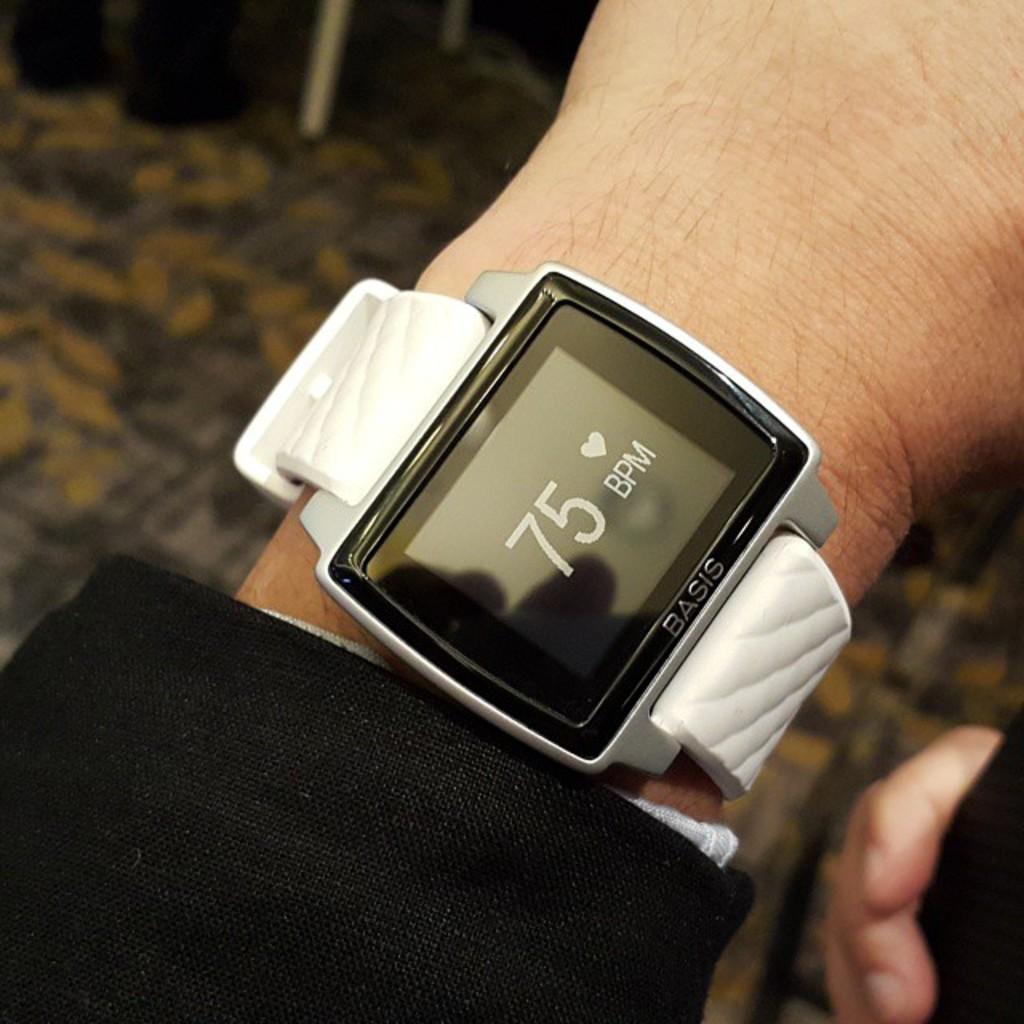What's the bpm?
Offer a terse response. 75. 